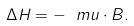Convert formula to latex. <formula><loc_0><loc_0><loc_500><loc_500>\Delta H = - \boldmath \ m u \cdot { B } .</formula> 